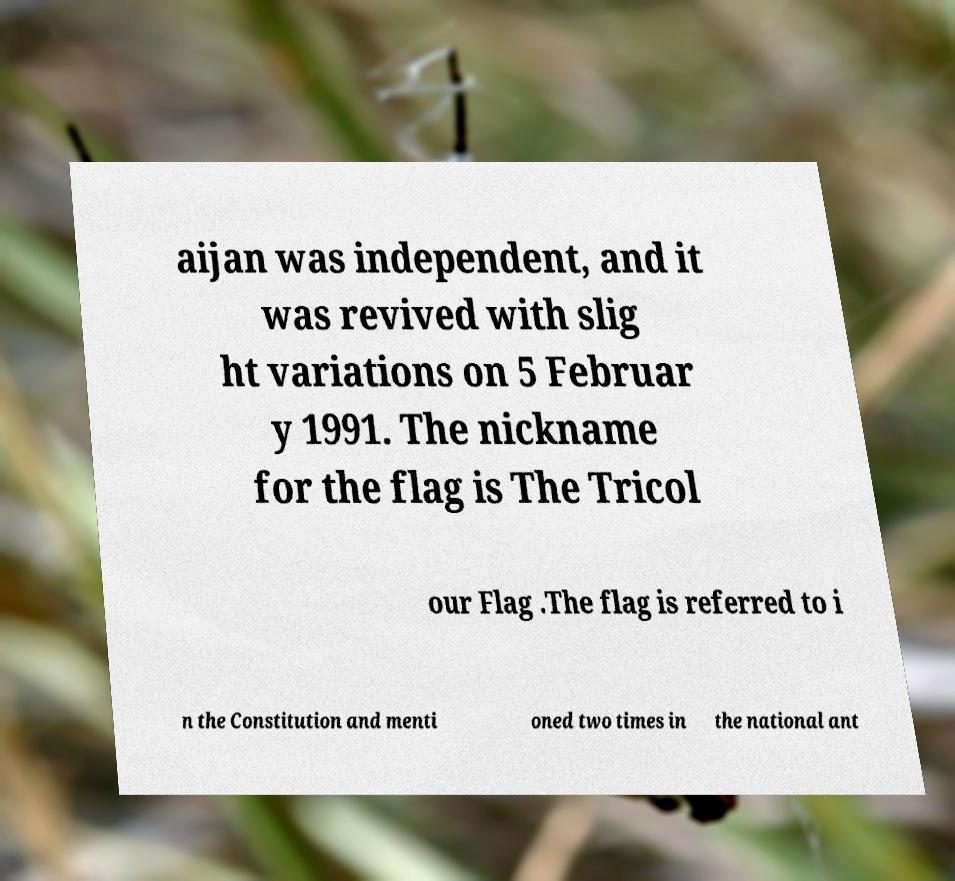Could you assist in decoding the text presented in this image and type it out clearly? aijan was independent, and it was revived with slig ht variations on 5 Februar y 1991. The nickname for the flag is The Tricol our Flag .The flag is referred to i n the Constitution and menti oned two times in the national ant 